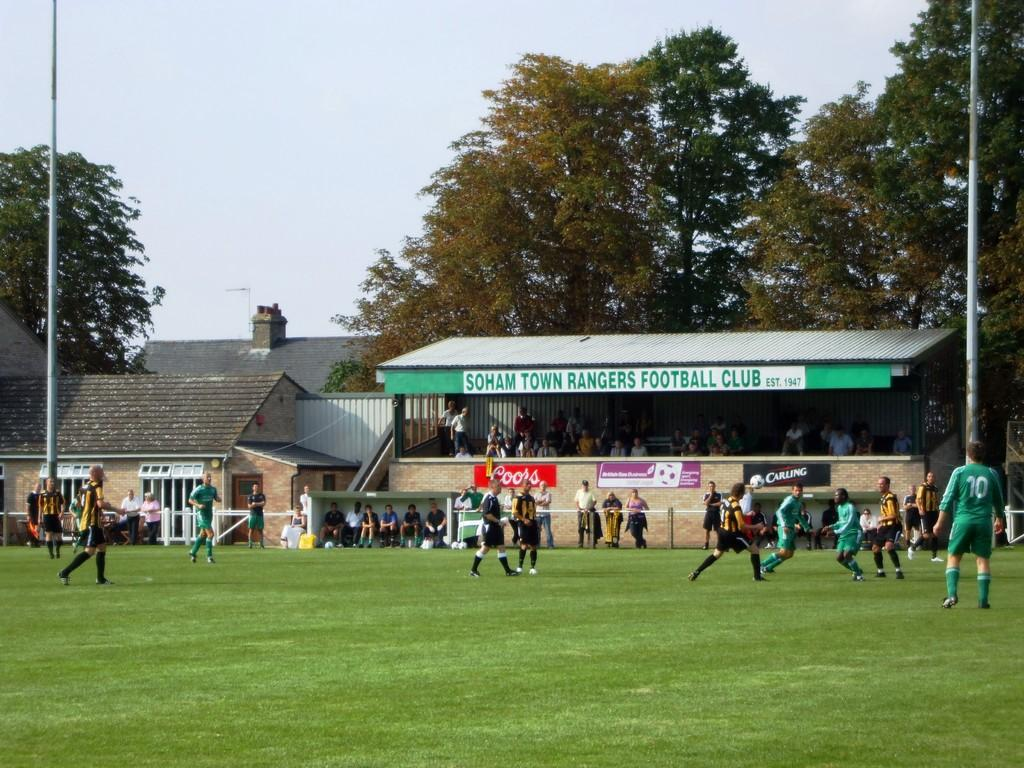<image>
Give a short and clear explanation of the subsequent image. A small section of bleachers is identified by a sign reading Football Club. 